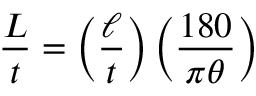Convert formula to latex. <formula><loc_0><loc_0><loc_500><loc_500>{ \frac { L } { t } } = \left ( { \frac { \ell } { t } } \right ) \left ( { \frac { 1 8 0 } { \pi \theta } } \right )</formula> 